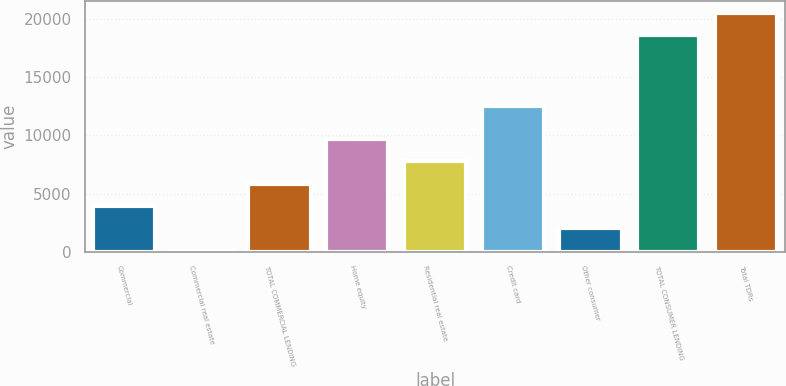Convert chart to OTSL. <chart><loc_0><loc_0><loc_500><loc_500><bar_chart><fcel>Commercial<fcel>Commercial real estate<fcel>TOTAL COMMERCIAL LENDING<fcel>Home equity<fcel>Residential real estate<fcel>Credit card<fcel>Other consumer<fcel>TOTAL CONSUMER LENDING<fcel>Total TDRs<nl><fcel>3926<fcel>78<fcel>5850<fcel>9698<fcel>7774<fcel>12564<fcel>2002<fcel>18639<fcel>20563<nl></chart> 